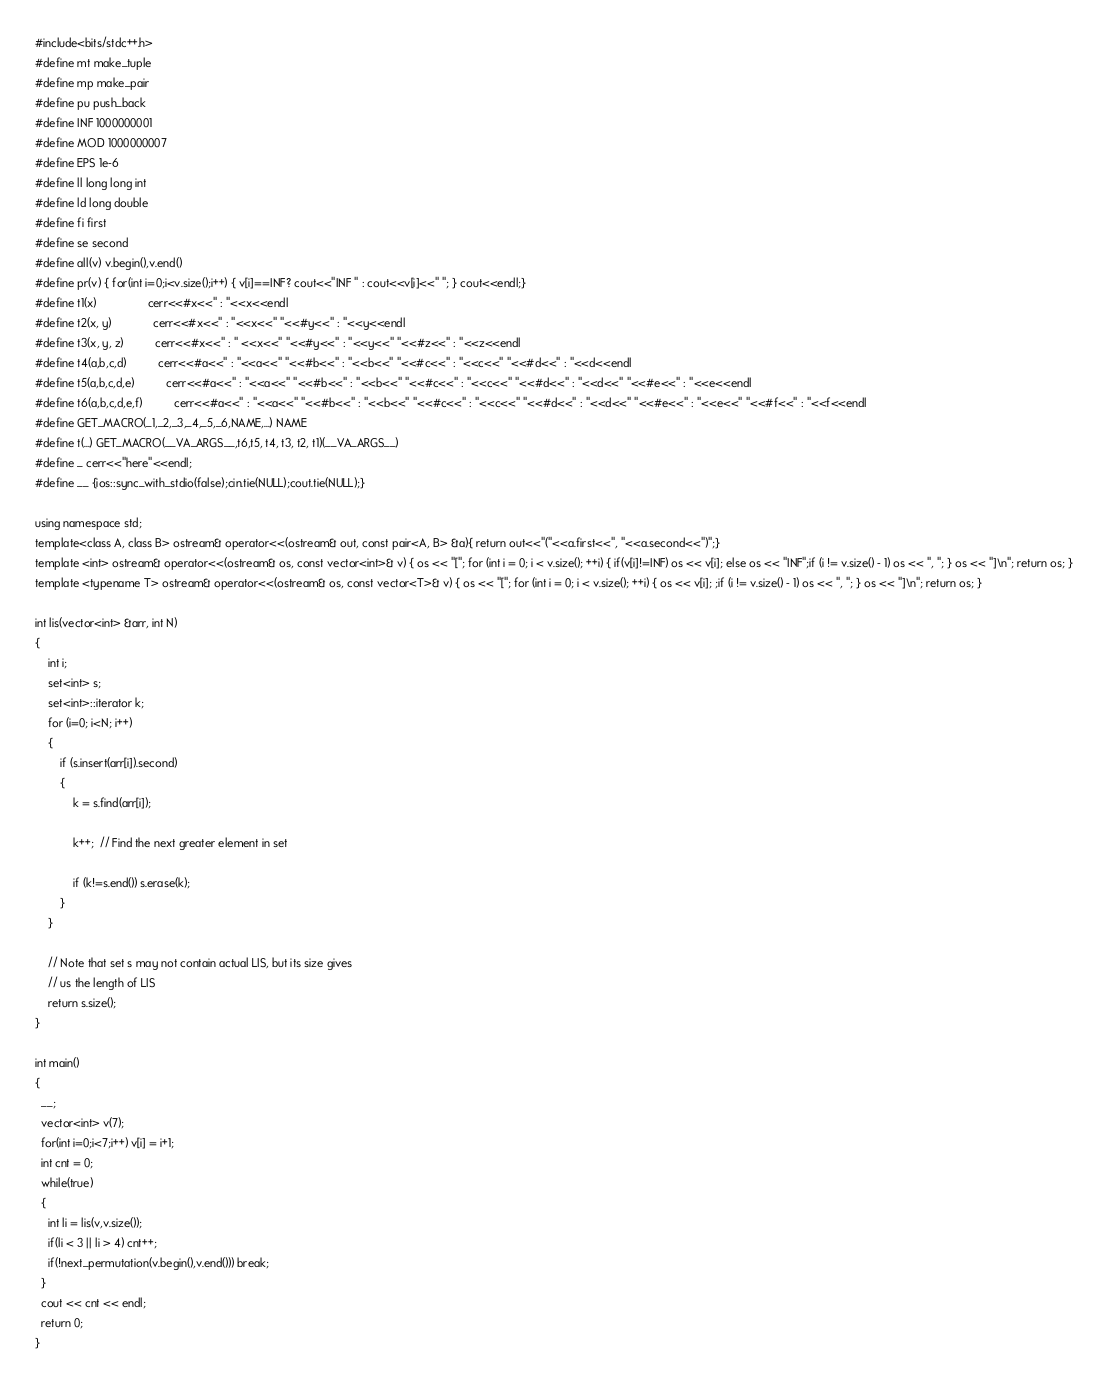<code> <loc_0><loc_0><loc_500><loc_500><_C++_>#include<bits/stdc++.h>
#define mt make_tuple
#define mp make_pair
#define pu push_back
#define INF 1000000001
#define MOD 1000000007
#define EPS 1e-6
#define ll long long int
#define ld long double
#define fi first
#define se second
#define all(v) v.begin(),v.end()
#define pr(v) { for(int i=0;i<v.size();i++) { v[i]==INF? cout<<"INF " : cout<<v[i]<<" "; } cout<<endl;}
#define t1(x)                cerr<<#x<<" : "<<x<<endl
#define t2(x, y)             cerr<<#x<<" : "<<x<<" "<<#y<<" : "<<y<<endl
#define t3(x, y, z)          cerr<<#x<<" : " <<x<<" "<<#y<<" : "<<y<<" "<<#z<<" : "<<z<<endl
#define t4(a,b,c,d)          cerr<<#a<<" : "<<a<<" "<<#b<<" : "<<b<<" "<<#c<<" : "<<c<<" "<<#d<<" : "<<d<<endl
#define t5(a,b,c,d,e)          cerr<<#a<<" : "<<a<<" "<<#b<<" : "<<b<<" "<<#c<<" : "<<c<<" "<<#d<<" : "<<d<<" "<<#e<<" : "<<e<<endl
#define t6(a,b,c,d,e,f)          cerr<<#a<<" : "<<a<<" "<<#b<<" : "<<b<<" "<<#c<<" : "<<c<<" "<<#d<<" : "<<d<<" "<<#e<<" : "<<e<<" "<<#f<<" : "<<f<<endl
#define GET_MACRO(_1,_2,_3,_4,_5,_6,NAME,...) NAME
#define t(...) GET_MACRO(__VA_ARGS__,t6,t5, t4, t3, t2, t1)(__VA_ARGS__)
#define _ cerr<<"here"<<endl;
#define __ {ios::sync_with_stdio(false);cin.tie(NULL);cout.tie(NULL);}

using namespace std;
template<class A, class B> ostream& operator<<(ostream& out, const pair<A, B> &a){ return out<<"("<<a.first<<", "<<a.second<<")";}
template <int> ostream& operator<<(ostream& os, const vector<int>& v) { os << "["; for (int i = 0; i < v.size(); ++i) { if(v[i]!=INF) os << v[i]; else os << "INF";if (i != v.size() - 1) os << ", "; } os << "]\n"; return os; } 
template <typename T> ostream& operator<<(ostream& os, const vector<T>& v) { os << "["; for (int i = 0; i < v.size(); ++i) { os << v[i]; ;if (i != v.size() - 1) os << ", "; } os << "]\n"; return os; } 

int lis(vector<int> &arr, int N) 
{ 
    int i; 
    set<int> s; 
    set<int>::iterator k; 
    for (i=0; i<N; i++) 
    { 
        if (s.insert(arr[i]).second) 
        { 
            k = s.find(arr[i]); 
  
            k++;  // Find the next greater element in set 
  
            if (k!=s.end()) s.erase(k); 
        } 
    } 
  
    // Note that set s may not contain actual LIS, but its size gives 
    // us the length of LIS 
    return s.size(); 
} 

int main()
{
  __;
  vector<int> v(7);
  for(int i=0;i<7;i++) v[i] = i+1;
  int cnt = 0;
  while(true)
  {
    int li = lis(v,v.size());
    if(li < 3 || li > 4) cnt++;
    if(!next_permutation(v.begin(),v.end())) break;
  } 
  cout << cnt << endl;
  return 0;
}
</code> 